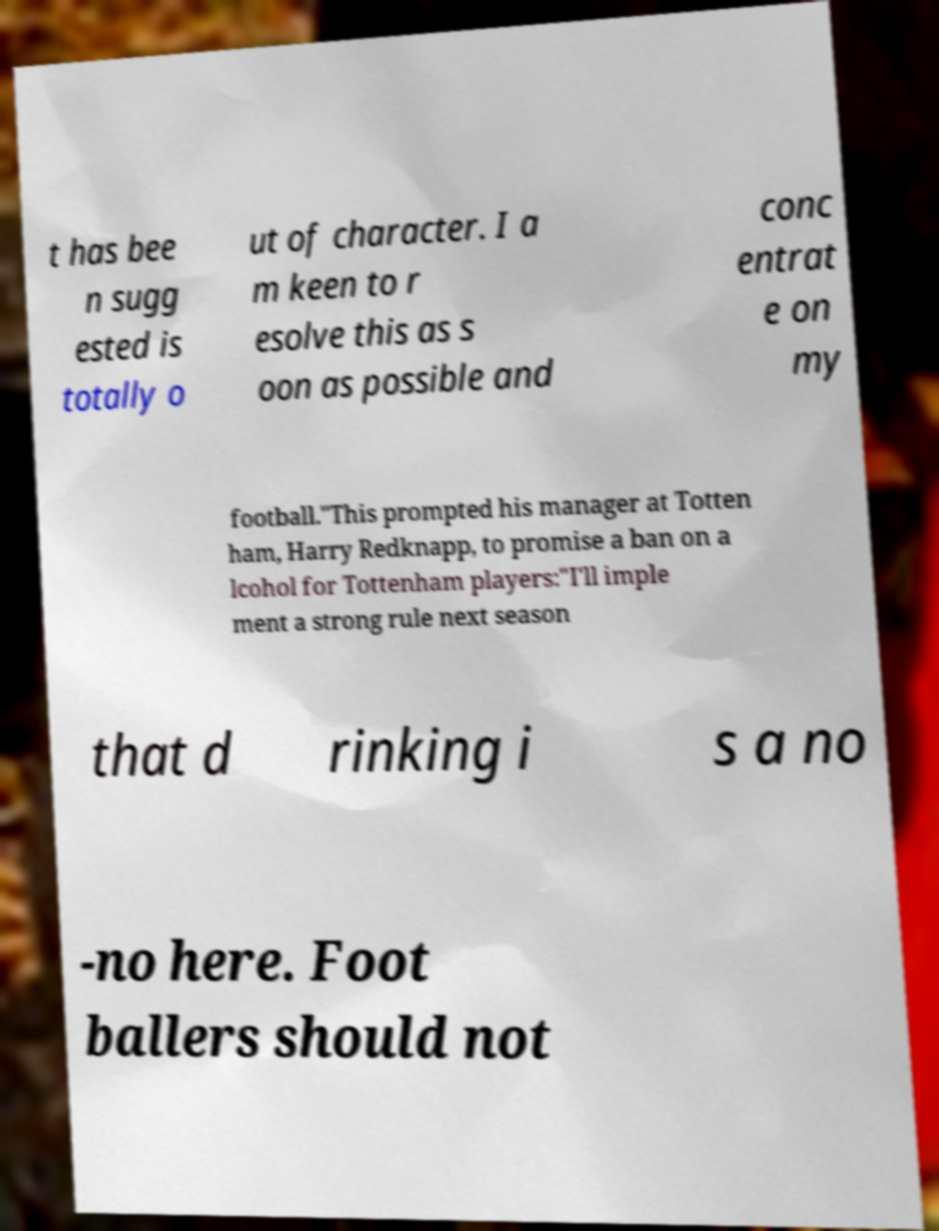There's text embedded in this image that I need extracted. Can you transcribe it verbatim? t has bee n sugg ested is totally o ut of character. I a m keen to r esolve this as s oon as possible and conc entrat e on my football."This prompted his manager at Totten ham, Harry Redknapp, to promise a ban on a lcohol for Tottenham players:"I'll imple ment a strong rule next season that d rinking i s a no -no here. Foot ballers should not 